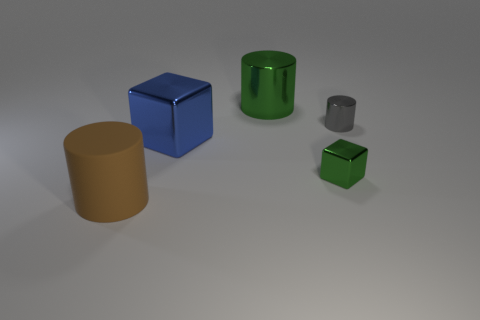Subtract all big green cylinders. How many cylinders are left? 2 Add 4 green metallic objects. How many objects exist? 9 Subtract all cylinders. How many objects are left? 2 Add 5 large matte cylinders. How many large matte cylinders exist? 6 Subtract 0 cyan spheres. How many objects are left? 5 Subtract all brown matte things. Subtract all blocks. How many objects are left? 2 Add 5 matte cylinders. How many matte cylinders are left? 6 